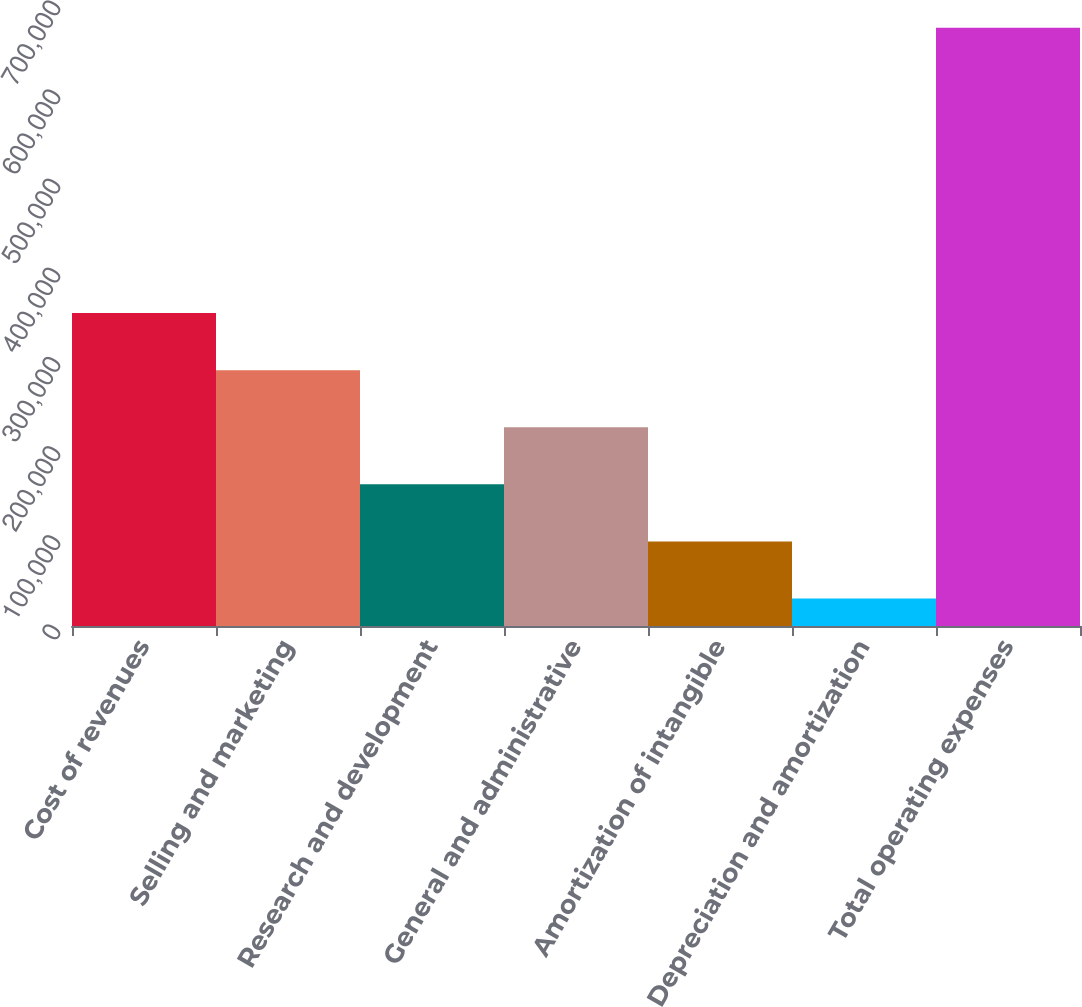<chart> <loc_0><loc_0><loc_500><loc_500><bar_chart><fcel>Cost of revenues<fcel>Selling and marketing<fcel>Research and development<fcel>General and administrative<fcel>Amortization of intangible<fcel>Depreciation and amortization<fcel>Total operating expenses<nl><fcel>351002<fcel>286979<fcel>158934<fcel>222957<fcel>94911.6<fcel>30889<fcel>671115<nl></chart> 